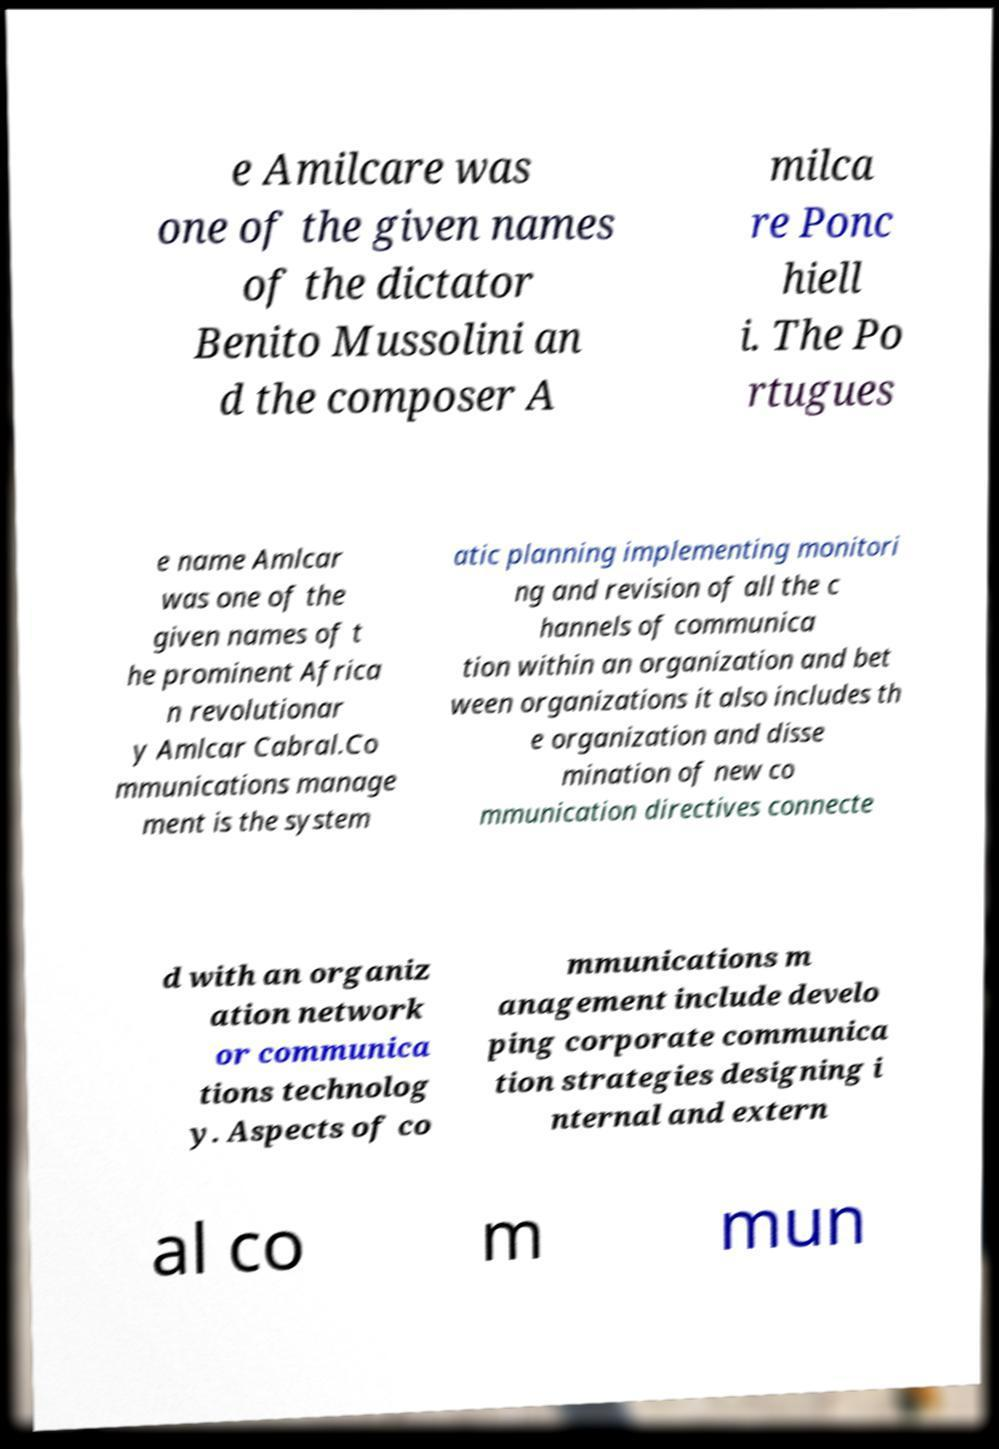Could you extract and type out the text from this image? e Amilcare was one of the given names of the dictator Benito Mussolini an d the composer A milca re Ponc hiell i. The Po rtugues e name Amlcar was one of the given names of t he prominent Africa n revolutionar y Amlcar Cabral.Co mmunications manage ment is the system atic planning implementing monitori ng and revision of all the c hannels of communica tion within an organization and bet ween organizations it also includes th e organization and disse mination of new co mmunication directives connecte d with an organiz ation network or communica tions technolog y. Aspects of co mmunications m anagement include develo ping corporate communica tion strategies designing i nternal and extern al co m mun 